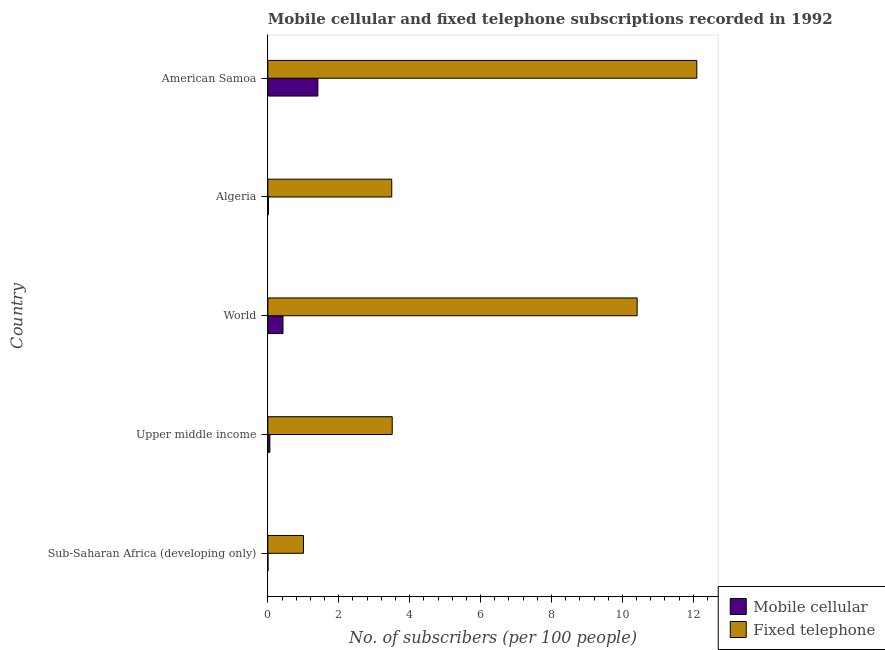How many different coloured bars are there?
Give a very brief answer. 2. Are the number of bars per tick equal to the number of legend labels?
Ensure brevity in your answer.  Yes. Are the number of bars on each tick of the Y-axis equal?
Offer a very short reply. Yes. How many bars are there on the 2nd tick from the top?
Make the answer very short. 2. What is the label of the 2nd group of bars from the top?
Provide a succinct answer. Algeria. In how many cases, is the number of bars for a given country not equal to the number of legend labels?
Offer a terse response. 0. What is the number of fixed telephone subscribers in Sub-Saharan Africa (developing only)?
Your answer should be compact. 1. Across all countries, what is the maximum number of fixed telephone subscribers?
Offer a very short reply. 12.1. Across all countries, what is the minimum number of mobile cellular subscribers?
Ensure brevity in your answer.  0. In which country was the number of fixed telephone subscribers maximum?
Offer a terse response. American Samoa. In which country was the number of mobile cellular subscribers minimum?
Offer a terse response. Sub-Saharan Africa (developing only). What is the total number of fixed telephone subscribers in the graph?
Your response must be concise. 30.52. What is the difference between the number of fixed telephone subscribers in American Samoa and that in Sub-Saharan Africa (developing only)?
Offer a terse response. 11.09. What is the difference between the number of fixed telephone subscribers in World and the number of mobile cellular subscribers in Upper middle income?
Give a very brief answer. 10.36. What is the average number of mobile cellular subscribers per country?
Offer a terse response. 0.38. What is the difference between the number of mobile cellular subscribers and number of fixed telephone subscribers in Sub-Saharan Africa (developing only)?
Offer a terse response. -1. What is the ratio of the number of mobile cellular subscribers in American Samoa to that in Upper middle income?
Keep it short and to the point. 24.85. Is the number of fixed telephone subscribers in Algeria less than that in World?
Ensure brevity in your answer.  Yes. Is the difference between the number of fixed telephone subscribers in Algeria and Upper middle income greater than the difference between the number of mobile cellular subscribers in Algeria and Upper middle income?
Your response must be concise. Yes. What is the difference between the highest and the second highest number of fixed telephone subscribers?
Ensure brevity in your answer.  1.68. What is the difference between the highest and the lowest number of mobile cellular subscribers?
Give a very brief answer. 1.41. In how many countries, is the number of mobile cellular subscribers greater than the average number of mobile cellular subscribers taken over all countries?
Ensure brevity in your answer.  2. What does the 1st bar from the top in Algeria represents?
Your response must be concise. Fixed telephone. What does the 1st bar from the bottom in World represents?
Ensure brevity in your answer.  Mobile cellular. How many countries are there in the graph?
Offer a very short reply. 5. Are the values on the major ticks of X-axis written in scientific E-notation?
Make the answer very short. No. Does the graph contain any zero values?
Provide a succinct answer. No. Does the graph contain grids?
Offer a terse response. No. Where does the legend appear in the graph?
Offer a terse response. Bottom right. How many legend labels are there?
Offer a terse response. 2. What is the title of the graph?
Give a very brief answer. Mobile cellular and fixed telephone subscriptions recorded in 1992. What is the label or title of the X-axis?
Offer a very short reply. No. of subscribers (per 100 people). What is the No. of subscribers (per 100 people) of Mobile cellular in Sub-Saharan Africa (developing only)?
Offer a terse response. 0. What is the No. of subscribers (per 100 people) of Fixed telephone in Sub-Saharan Africa (developing only)?
Give a very brief answer. 1. What is the No. of subscribers (per 100 people) in Mobile cellular in Upper middle income?
Provide a succinct answer. 0.06. What is the No. of subscribers (per 100 people) of Fixed telephone in Upper middle income?
Your answer should be very brief. 3.51. What is the No. of subscribers (per 100 people) in Mobile cellular in World?
Make the answer very short. 0.43. What is the No. of subscribers (per 100 people) of Fixed telephone in World?
Ensure brevity in your answer.  10.42. What is the No. of subscribers (per 100 people) in Mobile cellular in Algeria?
Your answer should be compact. 0.02. What is the No. of subscribers (per 100 people) in Fixed telephone in Algeria?
Make the answer very short. 3.49. What is the No. of subscribers (per 100 people) in Mobile cellular in American Samoa?
Your answer should be very brief. 1.41. What is the No. of subscribers (per 100 people) of Fixed telephone in American Samoa?
Your response must be concise. 12.1. Across all countries, what is the maximum No. of subscribers (per 100 people) of Mobile cellular?
Your answer should be very brief. 1.41. Across all countries, what is the maximum No. of subscribers (per 100 people) in Fixed telephone?
Make the answer very short. 12.1. Across all countries, what is the minimum No. of subscribers (per 100 people) in Mobile cellular?
Ensure brevity in your answer.  0. Across all countries, what is the minimum No. of subscribers (per 100 people) in Fixed telephone?
Provide a succinct answer. 1. What is the total No. of subscribers (per 100 people) in Mobile cellular in the graph?
Ensure brevity in your answer.  1.92. What is the total No. of subscribers (per 100 people) of Fixed telephone in the graph?
Offer a terse response. 30.52. What is the difference between the No. of subscribers (per 100 people) of Mobile cellular in Sub-Saharan Africa (developing only) and that in Upper middle income?
Offer a very short reply. -0.05. What is the difference between the No. of subscribers (per 100 people) of Fixed telephone in Sub-Saharan Africa (developing only) and that in Upper middle income?
Offer a very short reply. -2.5. What is the difference between the No. of subscribers (per 100 people) of Mobile cellular in Sub-Saharan Africa (developing only) and that in World?
Make the answer very short. -0.42. What is the difference between the No. of subscribers (per 100 people) in Fixed telephone in Sub-Saharan Africa (developing only) and that in World?
Your response must be concise. -9.41. What is the difference between the No. of subscribers (per 100 people) in Mobile cellular in Sub-Saharan Africa (developing only) and that in Algeria?
Your answer should be very brief. -0.01. What is the difference between the No. of subscribers (per 100 people) in Fixed telephone in Sub-Saharan Africa (developing only) and that in Algeria?
Your answer should be very brief. -2.49. What is the difference between the No. of subscribers (per 100 people) in Mobile cellular in Sub-Saharan Africa (developing only) and that in American Samoa?
Give a very brief answer. -1.41. What is the difference between the No. of subscribers (per 100 people) in Fixed telephone in Sub-Saharan Africa (developing only) and that in American Samoa?
Offer a very short reply. -11.09. What is the difference between the No. of subscribers (per 100 people) of Mobile cellular in Upper middle income and that in World?
Provide a succinct answer. -0.37. What is the difference between the No. of subscribers (per 100 people) of Fixed telephone in Upper middle income and that in World?
Offer a very short reply. -6.91. What is the difference between the No. of subscribers (per 100 people) in Mobile cellular in Upper middle income and that in Algeria?
Your response must be concise. 0.04. What is the difference between the No. of subscribers (per 100 people) in Fixed telephone in Upper middle income and that in Algeria?
Keep it short and to the point. 0.01. What is the difference between the No. of subscribers (per 100 people) of Mobile cellular in Upper middle income and that in American Samoa?
Provide a succinct answer. -1.35. What is the difference between the No. of subscribers (per 100 people) of Fixed telephone in Upper middle income and that in American Samoa?
Provide a succinct answer. -8.59. What is the difference between the No. of subscribers (per 100 people) in Mobile cellular in World and that in Algeria?
Offer a very short reply. 0.41. What is the difference between the No. of subscribers (per 100 people) in Fixed telephone in World and that in Algeria?
Offer a terse response. 6.92. What is the difference between the No. of subscribers (per 100 people) in Mobile cellular in World and that in American Samoa?
Offer a very short reply. -0.98. What is the difference between the No. of subscribers (per 100 people) of Fixed telephone in World and that in American Samoa?
Provide a short and direct response. -1.68. What is the difference between the No. of subscribers (per 100 people) in Mobile cellular in Algeria and that in American Samoa?
Your response must be concise. -1.39. What is the difference between the No. of subscribers (per 100 people) of Fixed telephone in Algeria and that in American Samoa?
Provide a short and direct response. -8.6. What is the difference between the No. of subscribers (per 100 people) in Mobile cellular in Sub-Saharan Africa (developing only) and the No. of subscribers (per 100 people) in Fixed telephone in Upper middle income?
Keep it short and to the point. -3.5. What is the difference between the No. of subscribers (per 100 people) in Mobile cellular in Sub-Saharan Africa (developing only) and the No. of subscribers (per 100 people) in Fixed telephone in World?
Offer a very short reply. -10.41. What is the difference between the No. of subscribers (per 100 people) of Mobile cellular in Sub-Saharan Africa (developing only) and the No. of subscribers (per 100 people) of Fixed telephone in Algeria?
Provide a short and direct response. -3.49. What is the difference between the No. of subscribers (per 100 people) of Mobile cellular in Sub-Saharan Africa (developing only) and the No. of subscribers (per 100 people) of Fixed telephone in American Samoa?
Offer a very short reply. -12.09. What is the difference between the No. of subscribers (per 100 people) in Mobile cellular in Upper middle income and the No. of subscribers (per 100 people) in Fixed telephone in World?
Offer a very short reply. -10.36. What is the difference between the No. of subscribers (per 100 people) of Mobile cellular in Upper middle income and the No. of subscribers (per 100 people) of Fixed telephone in Algeria?
Your answer should be compact. -3.44. What is the difference between the No. of subscribers (per 100 people) of Mobile cellular in Upper middle income and the No. of subscribers (per 100 people) of Fixed telephone in American Samoa?
Your answer should be very brief. -12.04. What is the difference between the No. of subscribers (per 100 people) of Mobile cellular in World and the No. of subscribers (per 100 people) of Fixed telephone in Algeria?
Your response must be concise. -3.07. What is the difference between the No. of subscribers (per 100 people) in Mobile cellular in World and the No. of subscribers (per 100 people) in Fixed telephone in American Samoa?
Ensure brevity in your answer.  -11.67. What is the difference between the No. of subscribers (per 100 people) of Mobile cellular in Algeria and the No. of subscribers (per 100 people) of Fixed telephone in American Samoa?
Offer a terse response. -12.08. What is the average No. of subscribers (per 100 people) in Mobile cellular per country?
Provide a short and direct response. 0.38. What is the average No. of subscribers (per 100 people) of Fixed telephone per country?
Give a very brief answer. 6.1. What is the difference between the No. of subscribers (per 100 people) of Mobile cellular and No. of subscribers (per 100 people) of Fixed telephone in Sub-Saharan Africa (developing only)?
Your answer should be very brief. -1. What is the difference between the No. of subscribers (per 100 people) of Mobile cellular and No. of subscribers (per 100 people) of Fixed telephone in Upper middle income?
Make the answer very short. -3.45. What is the difference between the No. of subscribers (per 100 people) of Mobile cellular and No. of subscribers (per 100 people) of Fixed telephone in World?
Make the answer very short. -9.99. What is the difference between the No. of subscribers (per 100 people) of Mobile cellular and No. of subscribers (per 100 people) of Fixed telephone in Algeria?
Your response must be concise. -3.48. What is the difference between the No. of subscribers (per 100 people) of Mobile cellular and No. of subscribers (per 100 people) of Fixed telephone in American Samoa?
Your answer should be very brief. -10.69. What is the ratio of the No. of subscribers (per 100 people) in Mobile cellular in Sub-Saharan Africa (developing only) to that in Upper middle income?
Provide a succinct answer. 0.06. What is the ratio of the No. of subscribers (per 100 people) in Fixed telephone in Sub-Saharan Africa (developing only) to that in Upper middle income?
Offer a very short reply. 0.29. What is the ratio of the No. of subscribers (per 100 people) of Mobile cellular in Sub-Saharan Africa (developing only) to that in World?
Provide a short and direct response. 0.01. What is the ratio of the No. of subscribers (per 100 people) of Fixed telephone in Sub-Saharan Africa (developing only) to that in World?
Offer a terse response. 0.1. What is the ratio of the No. of subscribers (per 100 people) of Mobile cellular in Sub-Saharan Africa (developing only) to that in Algeria?
Give a very brief answer. 0.2. What is the ratio of the No. of subscribers (per 100 people) of Fixed telephone in Sub-Saharan Africa (developing only) to that in Algeria?
Keep it short and to the point. 0.29. What is the ratio of the No. of subscribers (per 100 people) in Mobile cellular in Sub-Saharan Africa (developing only) to that in American Samoa?
Offer a very short reply. 0. What is the ratio of the No. of subscribers (per 100 people) of Fixed telephone in Sub-Saharan Africa (developing only) to that in American Samoa?
Your response must be concise. 0.08. What is the ratio of the No. of subscribers (per 100 people) of Mobile cellular in Upper middle income to that in World?
Your answer should be compact. 0.13. What is the ratio of the No. of subscribers (per 100 people) of Fixed telephone in Upper middle income to that in World?
Your response must be concise. 0.34. What is the ratio of the No. of subscribers (per 100 people) of Mobile cellular in Upper middle income to that in Algeria?
Offer a terse response. 3.27. What is the ratio of the No. of subscribers (per 100 people) of Mobile cellular in Upper middle income to that in American Samoa?
Provide a short and direct response. 0.04. What is the ratio of the No. of subscribers (per 100 people) in Fixed telephone in Upper middle income to that in American Samoa?
Your answer should be compact. 0.29. What is the ratio of the No. of subscribers (per 100 people) of Mobile cellular in World to that in Algeria?
Provide a succinct answer. 24.59. What is the ratio of the No. of subscribers (per 100 people) of Fixed telephone in World to that in Algeria?
Ensure brevity in your answer.  2.98. What is the ratio of the No. of subscribers (per 100 people) of Mobile cellular in World to that in American Samoa?
Give a very brief answer. 0.3. What is the ratio of the No. of subscribers (per 100 people) of Fixed telephone in World to that in American Samoa?
Your answer should be compact. 0.86. What is the ratio of the No. of subscribers (per 100 people) in Mobile cellular in Algeria to that in American Samoa?
Your answer should be very brief. 0.01. What is the ratio of the No. of subscribers (per 100 people) of Fixed telephone in Algeria to that in American Samoa?
Keep it short and to the point. 0.29. What is the difference between the highest and the second highest No. of subscribers (per 100 people) of Mobile cellular?
Provide a short and direct response. 0.98. What is the difference between the highest and the second highest No. of subscribers (per 100 people) in Fixed telephone?
Your answer should be very brief. 1.68. What is the difference between the highest and the lowest No. of subscribers (per 100 people) of Mobile cellular?
Give a very brief answer. 1.41. What is the difference between the highest and the lowest No. of subscribers (per 100 people) in Fixed telephone?
Give a very brief answer. 11.09. 